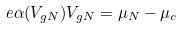<formula> <loc_0><loc_0><loc_500><loc_500>e \alpha ( V _ { g N } ) V _ { g N } = \mu _ { N } - \mu _ { c }</formula> 